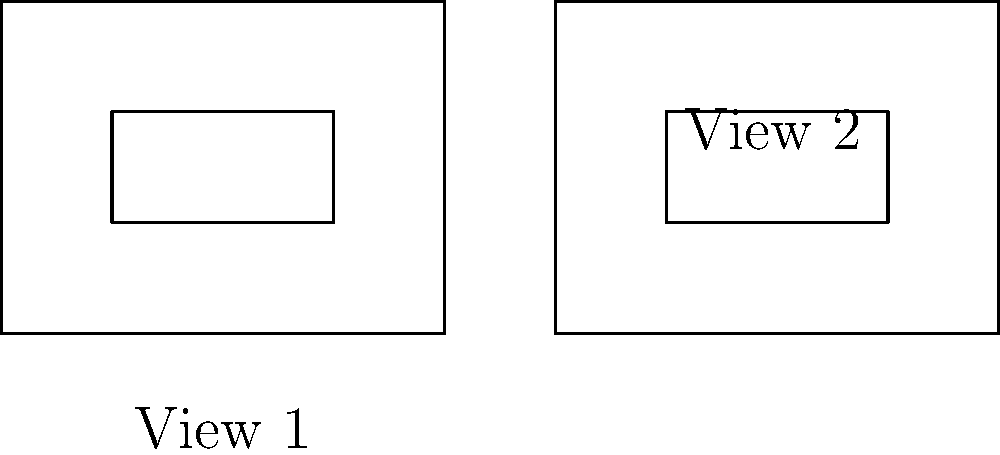As you walk around your neighborhood, you notice that the silhouette of a local landmark appears to change shape. The two views shown represent the landmark from different angles. Are these two silhouettes congruent? To determine if the two silhouettes are congruent, we need to follow these steps:

1. Examine the shape of both silhouettes:
   Both are rectangles with smaller rectangles inside them.

2. Compare the dimensions:
   a) Outer rectangles:
      View 1: 4 units wide, 3 units tall
      View 2: 4 units wide, 3 units tall
   b) Inner rectangles:
      View 1: 2 units wide, 1 unit tall
      View 2: 2 units wide, 1 unit tall

3. Check the position of inner rectangles:
   In both views, the inner rectangle is centered within the outer rectangle.

4. Apply the definition of congruence:
   Two shapes are congruent if they have the same size and shape.

5. Conclusion:
   Since both silhouettes have identical dimensions and proportions, they are congruent.

The change in appearance is due to the different viewing angles, but the actual shape remains the same.
Answer: Yes, congruent. 